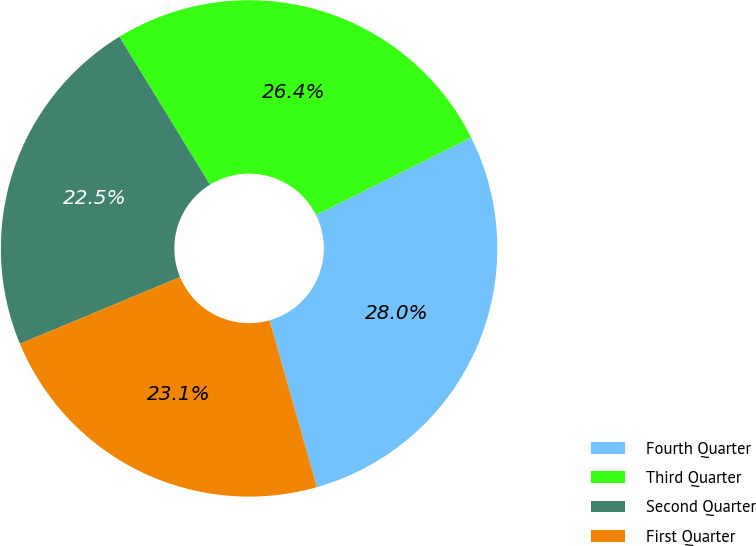<chart> <loc_0><loc_0><loc_500><loc_500><pie_chart><fcel>Fourth Quarter<fcel>Third Quarter<fcel>Second Quarter<fcel>First Quarter<nl><fcel>27.96%<fcel>26.39%<fcel>22.53%<fcel>23.13%<nl></chart> 